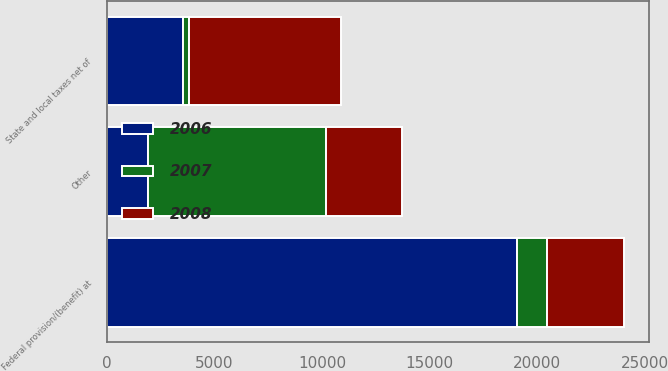<chart> <loc_0><loc_0><loc_500><loc_500><stacked_bar_chart><ecel><fcel>Federal provision/(benefit) at<fcel>State and local taxes net of<fcel>Other<nl><fcel>2007<fcel>1390<fcel>258<fcel>8283<nl><fcel>2008<fcel>3548<fcel>7089<fcel>3552<nl><fcel>2006<fcel>19083<fcel>3544<fcel>1900<nl></chart> 